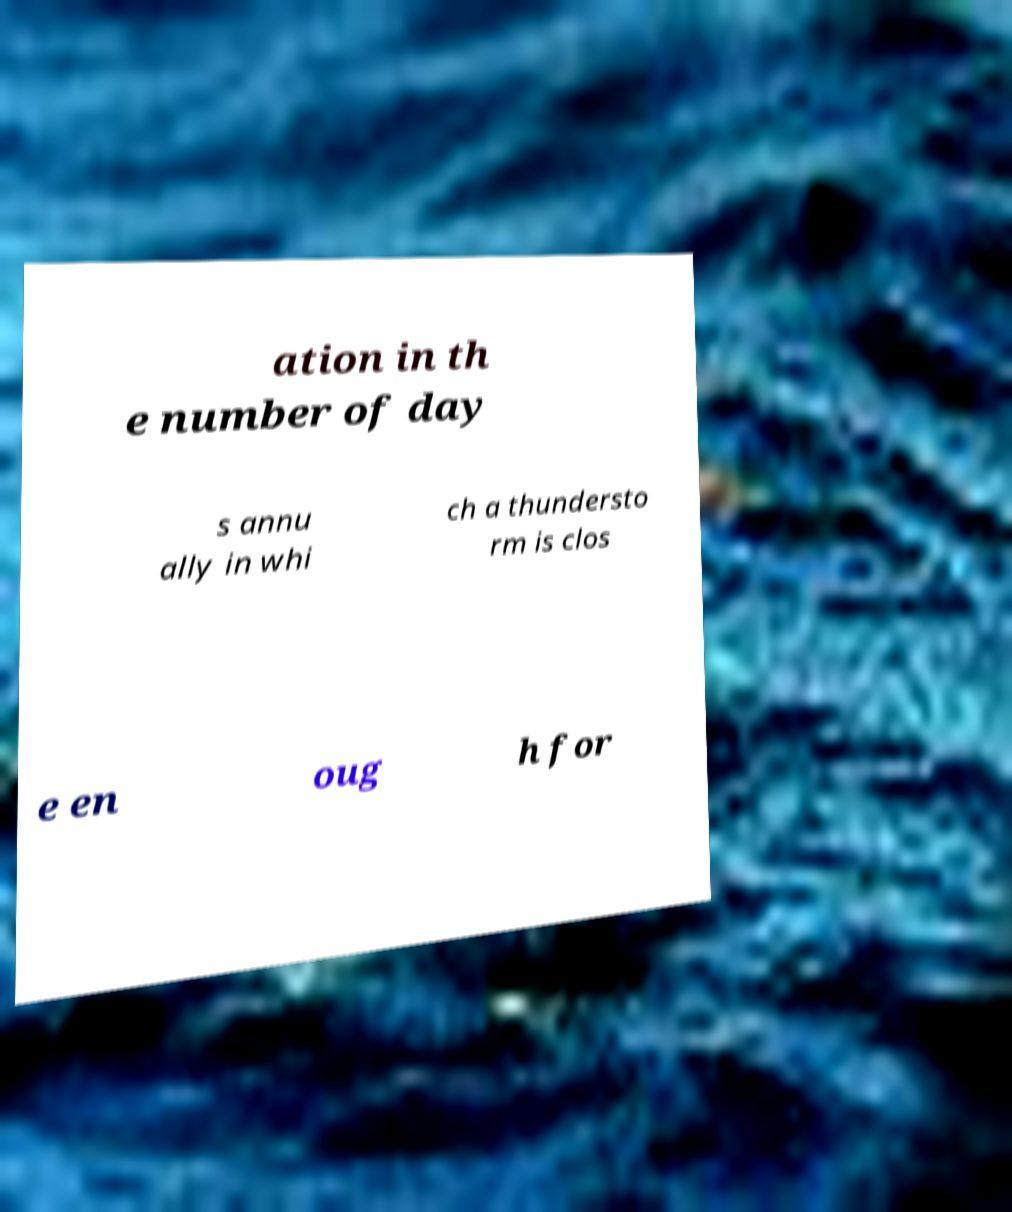Please read and relay the text visible in this image. What does it say? ation in th e number of day s annu ally in whi ch a thundersto rm is clos e en oug h for 